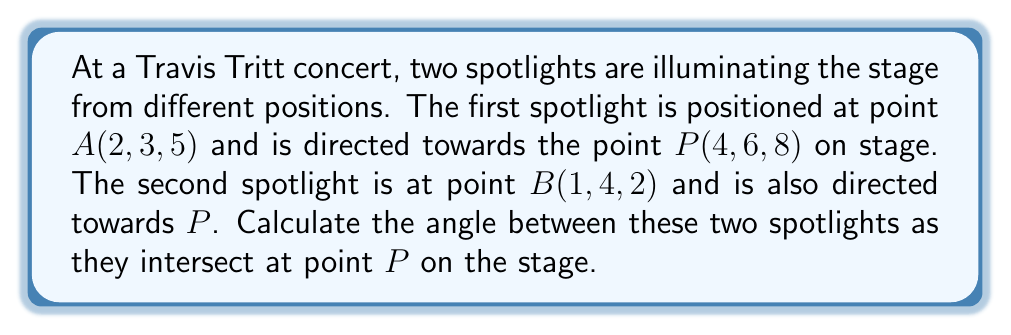Solve this math problem. Let's approach this step-by-step:

1) First, we need to find the vectors representing the direction of each spotlight:

   Vector $\vec{AP} = \overrightarrow{AP} = (4-2, 6-3, 8-5) = (2, 3, 3)$
   Vector $\vec{BP} = \overrightarrow{BP} = (4-1, 6-4, 8-2) = (3, 2, 6)$

2) The angle between these vectors can be calculated using the dot product formula:

   $$\cos \theta = \frac{\vec{AP} \cdot \vec{BP}}{|\vec{AP}| |\vec{BP}|}$$

3) Let's calculate the dot product $\vec{AP} \cdot \vec{BP}$:
   
   $\vec{AP} \cdot \vec{BP} = (2)(3) + (3)(2) + (3)(6) = 6 + 6 + 18 = 30$

4) Now, let's calculate the magnitudes:

   $|\vec{AP}| = \sqrt{2^2 + 3^2 + 3^2} = \sqrt{22}$
   $|\vec{BP}| = \sqrt{3^2 + 2^2 + 6^2} = \sqrt{49} = 7$

5) Substituting into the formula:

   $$\cos \theta = \frac{30}{\sqrt{22} \cdot 7}$$

6) To find $\theta$, we take the inverse cosine (arccos) of both sides:

   $$\theta = \arccos(\frac{30}{\sqrt{22} \cdot 7})$$

7) Using a calculator:

   $$\theta \approx 0.5389 \text{ radians}$$

8) Converting to degrees:

   $$\theta \approx 30.87°$$

[asy]
import geometry;

size(200);
currentprojection=perspective(6,3,2);

triple A=(2,3,5), B=(1,4,2), P=(4,6,8);

draw(A--P--B,blue);
draw(A--B,dashed);

dot("A",A,N);
dot("B",B,N);
dot("P",P,N);

draw(arc(P,0.5*(A-P),0.5*(B-P)),red,Arrow3);
label("$\theta$",P+(0.3,0.3,0.3),red);
[/asy]
Answer: $30.87°$ 